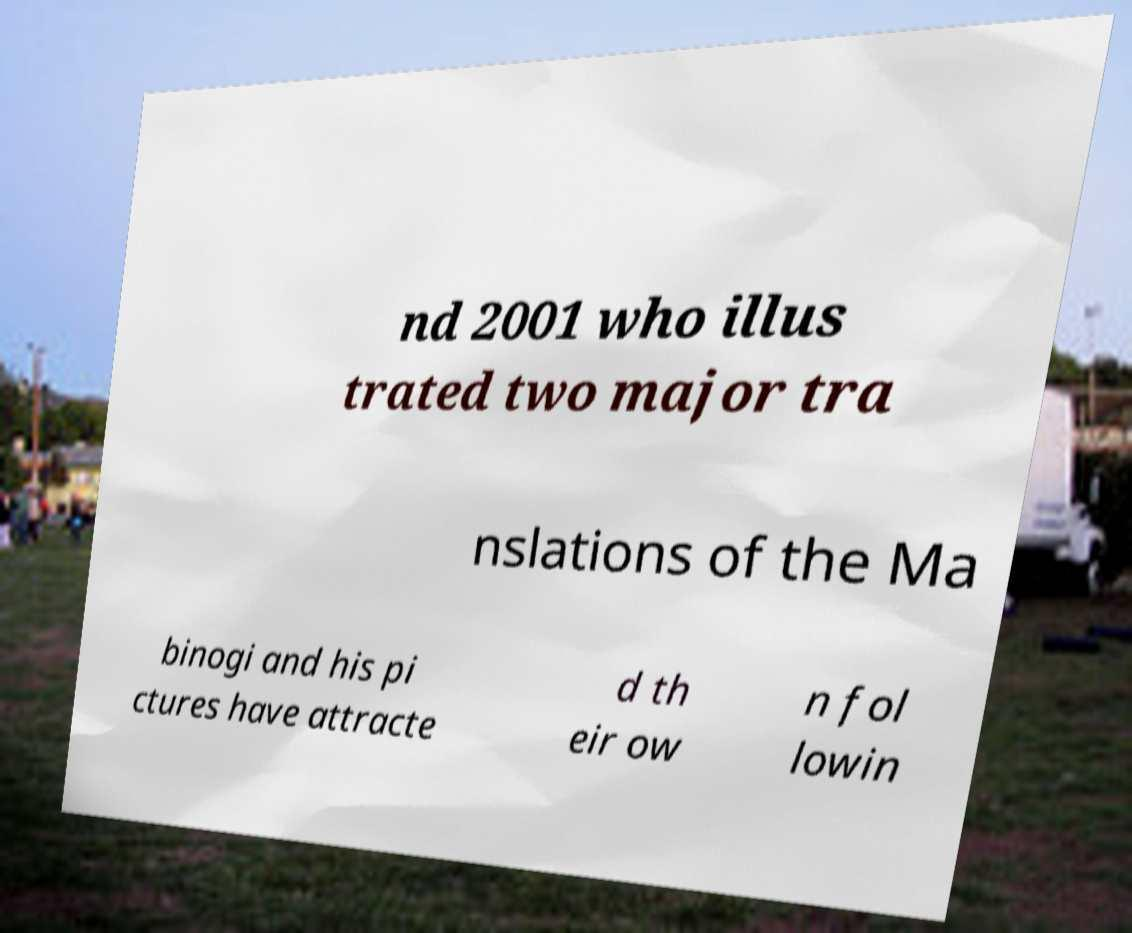Can you read and provide the text displayed in the image?This photo seems to have some interesting text. Can you extract and type it out for me? nd 2001 who illus trated two major tra nslations of the Ma binogi and his pi ctures have attracte d th eir ow n fol lowin 